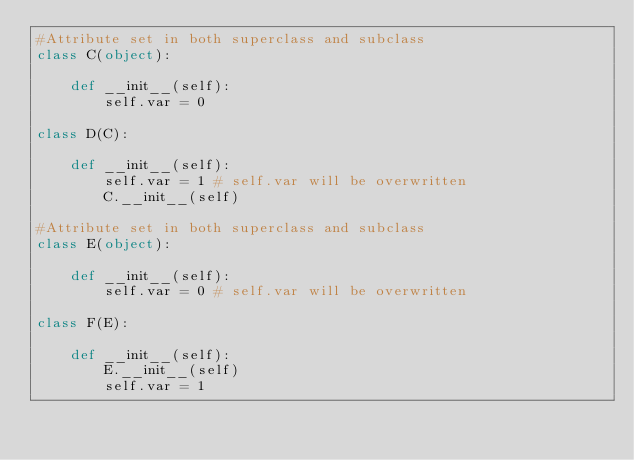Convert code to text. <code><loc_0><loc_0><loc_500><loc_500><_Python_>#Attribute set in both superclass and subclass
class C(object):

    def __init__(self):
        self.var = 0

class D(C):

    def __init__(self):
        self.var = 1 # self.var will be overwritten
        C.__init__(self)

#Attribute set in both superclass and subclass
class E(object):

    def __init__(self):
        self.var = 0 # self.var will be overwritten

class F(E):

    def __init__(self):
        E.__init__(self)
        self.var = 1
</code> 